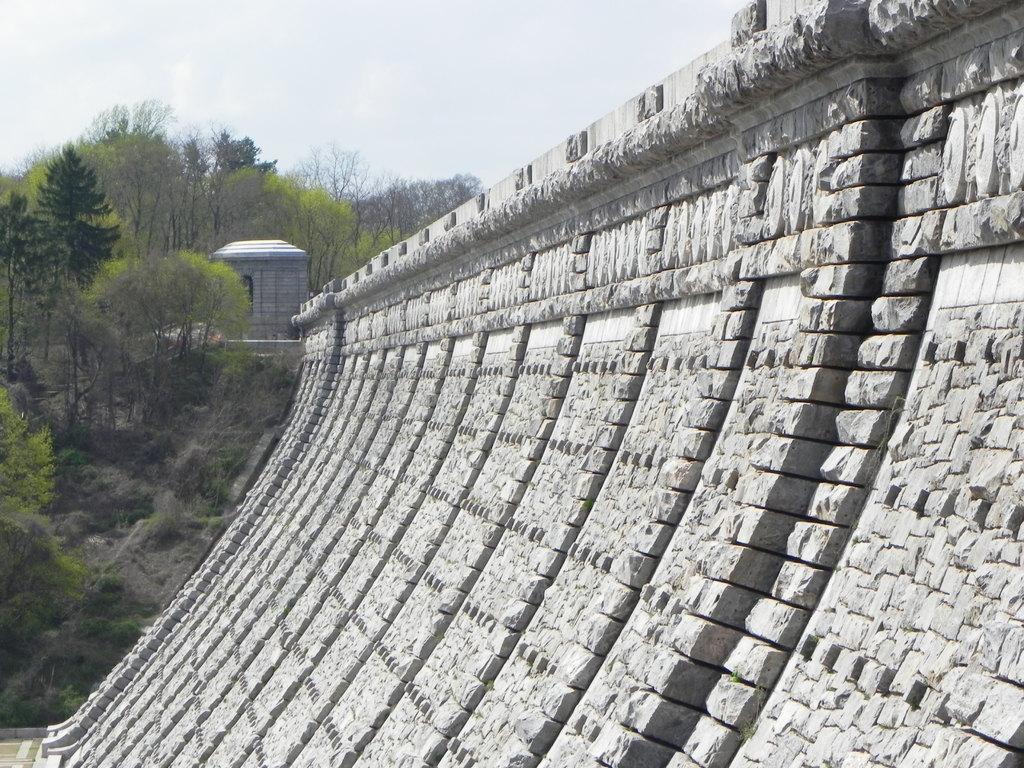Could you give a brief overview of what you see in this image? In this image we can see wall, creepers, trees and sky. 